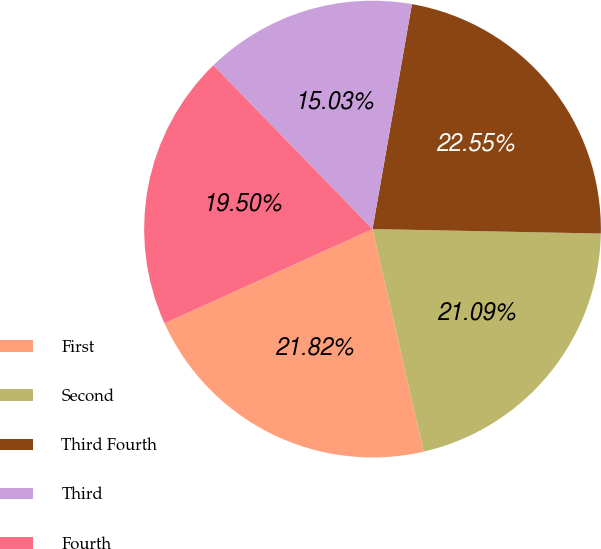<chart> <loc_0><loc_0><loc_500><loc_500><pie_chart><fcel>First<fcel>Second<fcel>Third Fourth<fcel>Third<fcel>Fourth<nl><fcel>21.82%<fcel>21.09%<fcel>22.55%<fcel>15.03%<fcel>19.5%<nl></chart> 